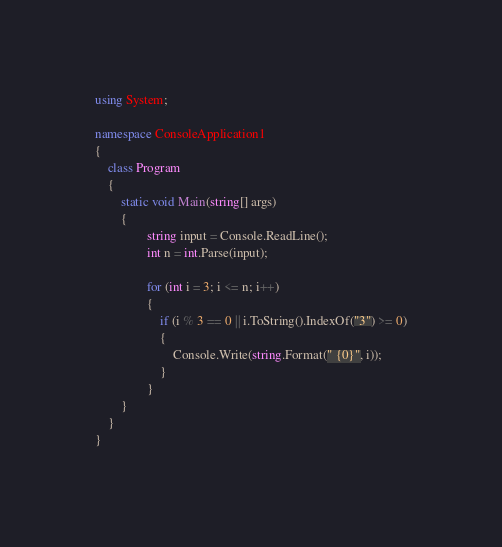<code> <loc_0><loc_0><loc_500><loc_500><_C#_>using System;

namespace ConsoleApplication1
{
    class Program
    {
        static void Main(string[] args)
        {          
                string input = Console.ReadLine();
                int n = int.Parse(input);

                for (int i = 3; i <= n; i++)
                {
                    if (i % 3 == 0 || i.ToString().IndexOf("3") >= 0)
                    {
                        Console.Write(string.Format(" {0}", i));
                    }          
                }
        }
    }
}</code> 